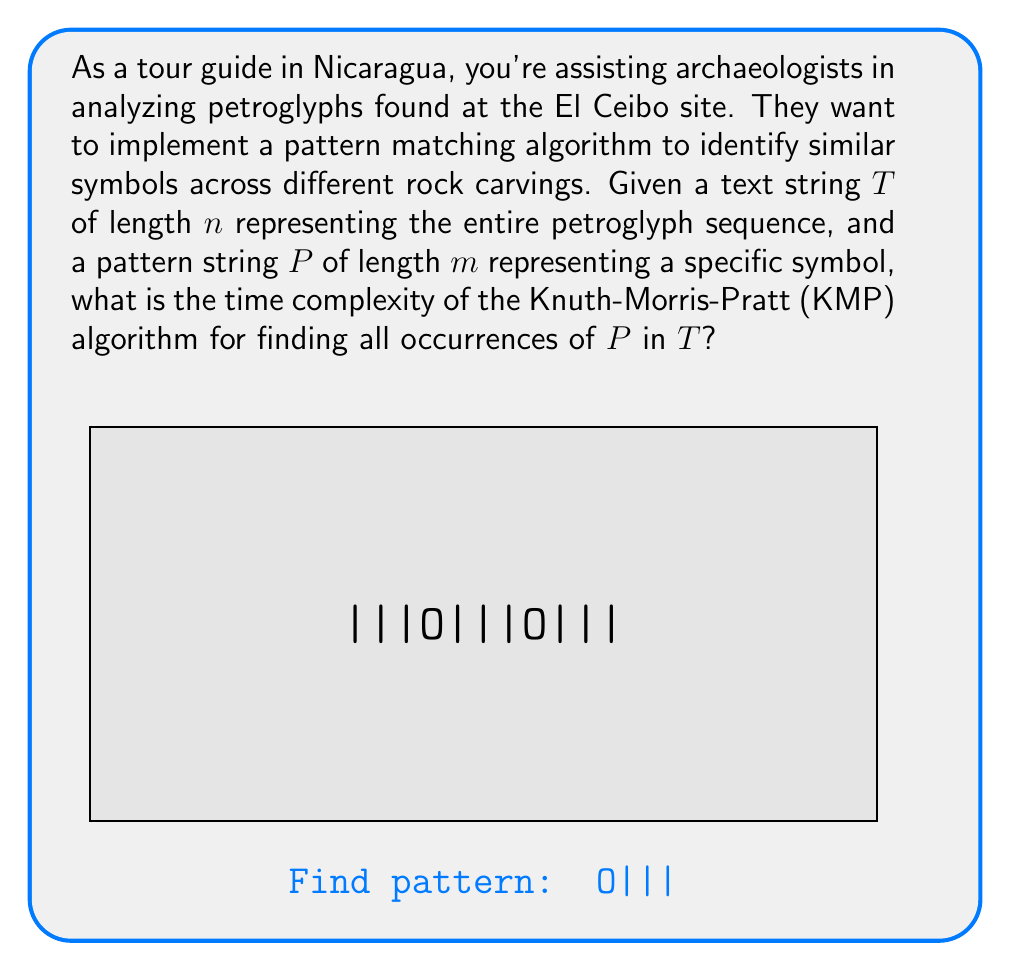Help me with this question. To analyze the time complexity of the Knuth-Morris-Pratt (KMP) algorithm for pattern matching in Nicaraguan archaeological data, let's break it down step-by-step:

1) The KMP algorithm consists of two main parts:
   a) Preprocessing of the pattern $P$
   b) Searching for the pattern in the text $T$

2) Preprocessing step:
   - This step computes the failure function (also known as the prefix function) for the pattern $P$.
   - Time complexity: $O(m)$, where $m$ is the length of the pattern.

3) Searching step:
   - The algorithm scans the text $T$ once, comparing it with the pattern $P$.
   - In the worst case, it performs $O(n)$ comparisons, where $n$ is the length of the text.
   - Each comparison takes constant time.
   - Time complexity: $O(n)$

4) Total time complexity:
   - Combining both steps: $O(m) + O(n) = O(m + n)$

5) In the context of Nicaraguan petroglyphs:
   - $T$ represents the entire sequence of symbols in a rock carving.
   - $P$ represents a specific symbol or pattern we're searching for.
   - Usually, $m \ll n$ (the pattern is much shorter than the text).

6) Therefore, the time complexity simplifies to $O(n)$ in most practical cases, as the length of the text dominates.

This efficient linear-time complexity makes the KMP algorithm suitable for analyzing large amounts of archaeological data from Nicaraguan sites like El Ceibo.
Answer: $O(m + n)$, where $m$ is the pattern length and $n$ is the text length. 